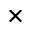Convert formula to latex. <formula><loc_0><loc_0><loc_500><loc_500>\times</formula> 